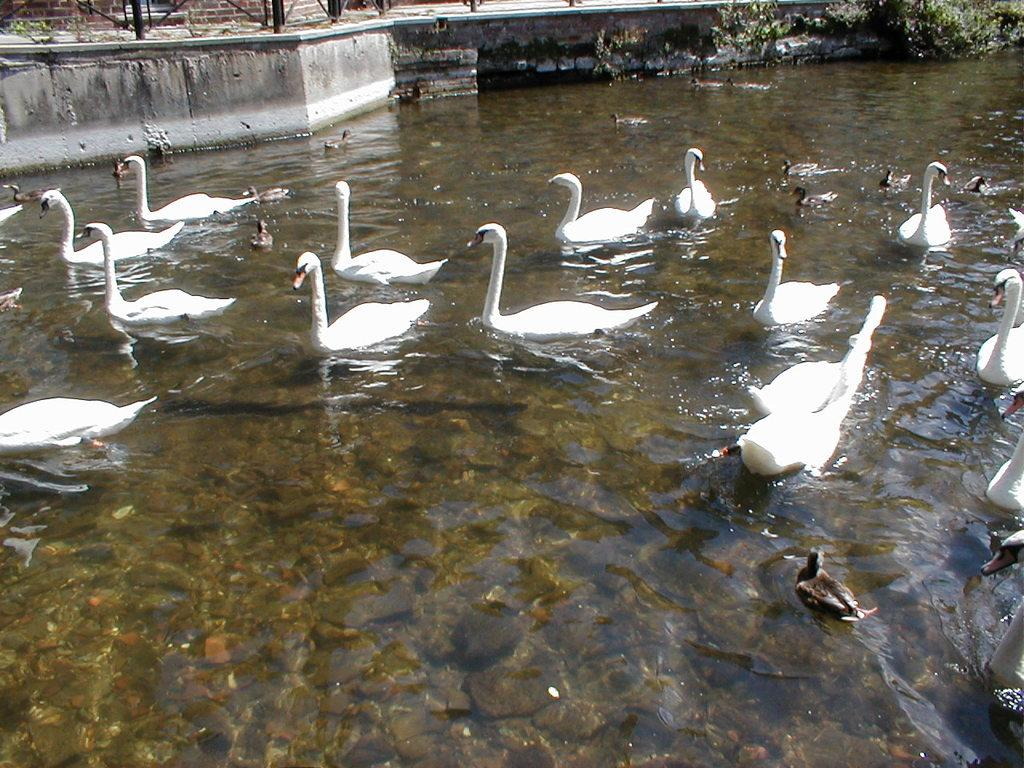What animals can be seen in the water in the image? There are ducks and swans in the water in the image. What type of structure is located near the water? There is a wall near the water in the image. What type of vegetation is present in the image? There are plants in the image. What type of wall can be seen at the top of the image? There is a brick wall visible at the top of the image. What can be found in the water besides the animals? There are stones in the water in the image. What rhythm do the babies follow while walking along the route in the image? There are no babies or routes present in the image; it features ducks, swans, a wall, plants, and stones in the water. 